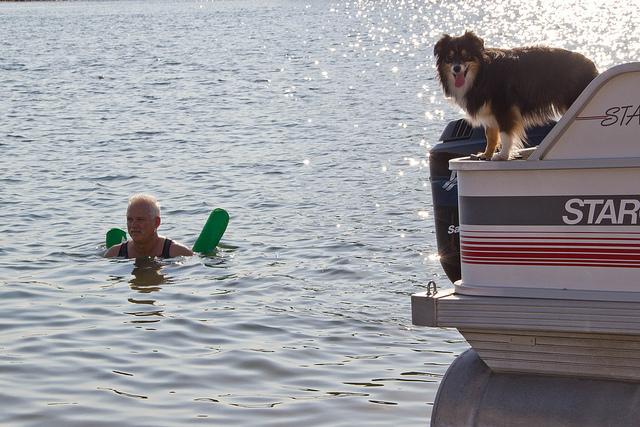What is the green object by the swimmer?
Give a very brief answer. Floatation device. Is the dog swimming in the lake?
Give a very brief answer. No. What color is the boat?
Keep it brief. White. 